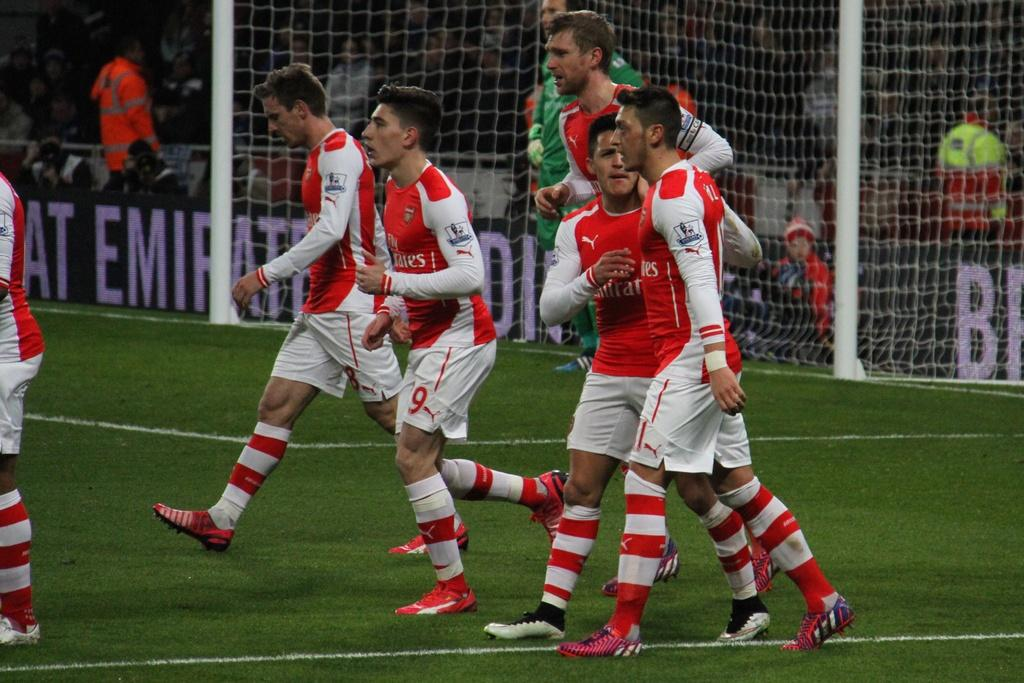<image>
Relay a brief, clear account of the picture shown. A soccer team is walking onto the field and the stadium wall says Emirate. 